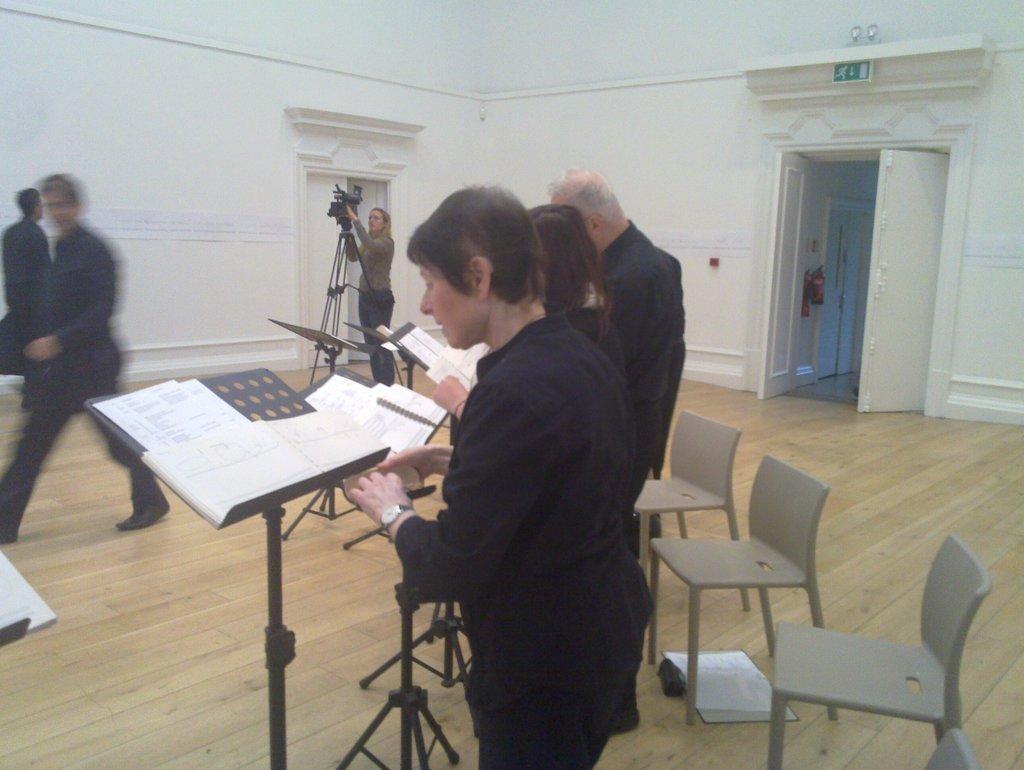Can you describe this image briefly? In this image, Few peoples are standing near the stands. We can see some papers, chairs on the right side, white wall, white door, board. In the middle, woman is holding a camera. On left side, a man is walking on the floor. 